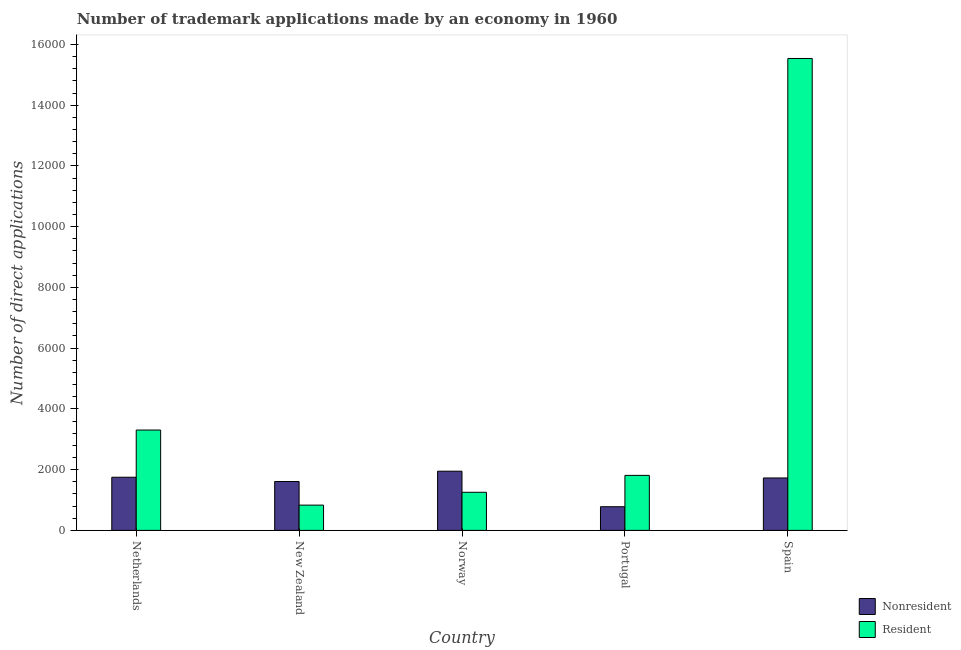How many different coloured bars are there?
Make the answer very short. 2. How many groups of bars are there?
Provide a succinct answer. 5. Are the number of bars per tick equal to the number of legend labels?
Make the answer very short. Yes. Are the number of bars on each tick of the X-axis equal?
Keep it short and to the point. Yes. How many bars are there on the 4th tick from the left?
Offer a very short reply. 2. How many bars are there on the 5th tick from the right?
Keep it short and to the point. 2. What is the number of trademark applications made by residents in New Zealand?
Offer a terse response. 832. Across all countries, what is the maximum number of trademark applications made by non residents?
Give a very brief answer. 1949. Across all countries, what is the minimum number of trademark applications made by non residents?
Offer a very short reply. 779. In which country was the number of trademark applications made by non residents maximum?
Give a very brief answer. Norway. In which country was the number of trademark applications made by residents minimum?
Ensure brevity in your answer.  New Zealand. What is the total number of trademark applications made by non residents in the graph?
Your answer should be very brief. 7813. What is the difference between the number of trademark applications made by residents in New Zealand and that in Portugal?
Your answer should be compact. -979. What is the difference between the number of trademark applications made by residents in Norway and the number of trademark applications made by non residents in Spain?
Your response must be concise. -471. What is the average number of trademark applications made by residents per country?
Offer a very short reply. 4547.8. What is the difference between the number of trademark applications made by non residents and number of trademark applications made by residents in Spain?
Make the answer very short. -1.38e+04. What is the ratio of the number of trademark applications made by residents in Portugal to that in Spain?
Offer a very short reply. 0.12. Is the number of trademark applications made by non residents in New Zealand less than that in Norway?
Ensure brevity in your answer.  Yes. What is the difference between the highest and the second highest number of trademark applications made by non residents?
Your answer should be very brief. 199. What is the difference between the highest and the lowest number of trademark applications made by non residents?
Offer a very short reply. 1170. Is the sum of the number of trademark applications made by residents in Netherlands and Portugal greater than the maximum number of trademark applications made by non residents across all countries?
Keep it short and to the point. Yes. What does the 1st bar from the left in New Zealand represents?
Your response must be concise. Nonresident. What does the 1st bar from the right in Norway represents?
Provide a short and direct response. Resident. Are all the bars in the graph horizontal?
Make the answer very short. No. Are the values on the major ticks of Y-axis written in scientific E-notation?
Your response must be concise. No. Where does the legend appear in the graph?
Offer a very short reply. Bottom right. What is the title of the graph?
Your answer should be very brief. Number of trademark applications made by an economy in 1960. Does "GDP" appear as one of the legend labels in the graph?
Give a very brief answer. No. What is the label or title of the X-axis?
Ensure brevity in your answer.  Country. What is the label or title of the Y-axis?
Your answer should be compact. Number of direct applications. What is the Number of direct applications of Nonresident in Netherlands?
Keep it short and to the point. 1750. What is the Number of direct applications in Resident in Netherlands?
Offer a terse response. 3304. What is the Number of direct applications in Nonresident in New Zealand?
Give a very brief answer. 1609. What is the Number of direct applications of Resident in New Zealand?
Offer a terse response. 832. What is the Number of direct applications in Nonresident in Norway?
Give a very brief answer. 1949. What is the Number of direct applications of Resident in Norway?
Provide a short and direct response. 1255. What is the Number of direct applications in Nonresident in Portugal?
Offer a terse response. 779. What is the Number of direct applications in Resident in Portugal?
Offer a very short reply. 1811. What is the Number of direct applications in Nonresident in Spain?
Keep it short and to the point. 1726. What is the Number of direct applications in Resident in Spain?
Your response must be concise. 1.55e+04. Across all countries, what is the maximum Number of direct applications of Nonresident?
Make the answer very short. 1949. Across all countries, what is the maximum Number of direct applications of Resident?
Provide a short and direct response. 1.55e+04. Across all countries, what is the minimum Number of direct applications in Nonresident?
Offer a very short reply. 779. Across all countries, what is the minimum Number of direct applications of Resident?
Your answer should be very brief. 832. What is the total Number of direct applications in Nonresident in the graph?
Offer a very short reply. 7813. What is the total Number of direct applications in Resident in the graph?
Your answer should be very brief. 2.27e+04. What is the difference between the Number of direct applications of Nonresident in Netherlands and that in New Zealand?
Your answer should be compact. 141. What is the difference between the Number of direct applications in Resident in Netherlands and that in New Zealand?
Your answer should be compact. 2472. What is the difference between the Number of direct applications of Nonresident in Netherlands and that in Norway?
Your answer should be compact. -199. What is the difference between the Number of direct applications in Resident in Netherlands and that in Norway?
Give a very brief answer. 2049. What is the difference between the Number of direct applications in Nonresident in Netherlands and that in Portugal?
Provide a succinct answer. 971. What is the difference between the Number of direct applications in Resident in Netherlands and that in Portugal?
Your answer should be compact. 1493. What is the difference between the Number of direct applications in Nonresident in Netherlands and that in Spain?
Offer a very short reply. 24. What is the difference between the Number of direct applications of Resident in Netherlands and that in Spain?
Make the answer very short. -1.22e+04. What is the difference between the Number of direct applications of Nonresident in New Zealand and that in Norway?
Provide a short and direct response. -340. What is the difference between the Number of direct applications of Resident in New Zealand and that in Norway?
Make the answer very short. -423. What is the difference between the Number of direct applications in Nonresident in New Zealand and that in Portugal?
Your response must be concise. 830. What is the difference between the Number of direct applications of Resident in New Zealand and that in Portugal?
Offer a very short reply. -979. What is the difference between the Number of direct applications in Nonresident in New Zealand and that in Spain?
Offer a terse response. -117. What is the difference between the Number of direct applications of Resident in New Zealand and that in Spain?
Your answer should be compact. -1.47e+04. What is the difference between the Number of direct applications in Nonresident in Norway and that in Portugal?
Make the answer very short. 1170. What is the difference between the Number of direct applications in Resident in Norway and that in Portugal?
Keep it short and to the point. -556. What is the difference between the Number of direct applications of Nonresident in Norway and that in Spain?
Provide a succinct answer. 223. What is the difference between the Number of direct applications in Resident in Norway and that in Spain?
Ensure brevity in your answer.  -1.43e+04. What is the difference between the Number of direct applications of Nonresident in Portugal and that in Spain?
Your answer should be very brief. -947. What is the difference between the Number of direct applications in Resident in Portugal and that in Spain?
Give a very brief answer. -1.37e+04. What is the difference between the Number of direct applications of Nonresident in Netherlands and the Number of direct applications of Resident in New Zealand?
Keep it short and to the point. 918. What is the difference between the Number of direct applications of Nonresident in Netherlands and the Number of direct applications of Resident in Norway?
Ensure brevity in your answer.  495. What is the difference between the Number of direct applications in Nonresident in Netherlands and the Number of direct applications in Resident in Portugal?
Offer a very short reply. -61. What is the difference between the Number of direct applications in Nonresident in Netherlands and the Number of direct applications in Resident in Spain?
Offer a terse response. -1.38e+04. What is the difference between the Number of direct applications in Nonresident in New Zealand and the Number of direct applications in Resident in Norway?
Your response must be concise. 354. What is the difference between the Number of direct applications in Nonresident in New Zealand and the Number of direct applications in Resident in Portugal?
Offer a very short reply. -202. What is the difference between the Number of direct applications in Nonresident in New Zealand and the Number of direct applications in Resident in Spain?
Keep it short and to the point. -1.39e+04. What is the difference between the Number of direct applications in Nonresident in Norway and the Number of direct applications in Resident in Portugal?
Make the answer very short. 138. What is the difference between the Number of direct applications in Nonresident in Norway and the Number of direct applications in Resident in Spain?
Keep it short and to the point. -1.36e+04. What is the difference between the Number of direct applications of Nonresident in Portugal and the Number of direct applications of Resident in Spain?
Offer a very short reply. -1.48e+04. What is the average Number of direct applications in Nonresident per country?
Your response must be concise. 1562.6. What is the average Number of direct applications of Resident per country?
Offer a terse response. 4547.8. What is the difference between the Number of direct applications of Nonresident and Number of direct applications of Resident in Netherlands?
Offer a terse response. -1554. What is the difference between the Number of direct applications in Nonresident and Number of direct applications in Resident in New Zealand?
Your answer should be compact. 777. What is the difference between the Number of direct applications of Nonresident and Number of direct applications of Resident in Norway?
Provide a succinct answer. 694. What is the difference between the Number of direct applications in Nonresident and Number of direct applications in Resident in Portugal?
Your answer should be very brief. -1032. What is the difference between the Number of direct applications in Nonresident and Number of direct applications in Resident in Spain?
Your response must be concise. -1.38e+04. What is the ratio of the Number of direct applications of Nonresident in Netherlands to that in New Zealand?
Give a very brief answer. 1.09. What is the ratio of the Number of direct applications in Resident in Netherlands to that in New Zealand?
Offer a very short reply. 3.97. What is the ratio of the Number of direct applications of Nonresident in Netherlands to that in Norway?
Your response must be concise. 0.9. What is the ratio of the Number of direct applications in Resident in Netherlands to that in Norway?
Your response must be concise. 2.63. What is the ratio of the Number of direct applications in Nonresident in Netherlands to that in Portugal?
Offer a very short reply. 2.25. What is the ratio of the Number of direct applications of Resident in Netherlands to that in Portugal?
Your response must be concise. 1.82. What is the ratio of the Number of direct applications in Nonresident in Netherlands to that in Spain?
Make the answer very short. 1.01. What is the ratio of the Number of direct applications in Resident in Netherlands to that in Spain?
Offer a terse response. 0.21. What is the ratio of the Number of direct applications of Nonresident in New Zealand to that in Norway?
Provide a short and direct response. 0.83. What is the ratio of the Number of direct applications of Resident in New Zealand to that in Norway?
Make the answer very short. 0.66. What is the ratio of the Number of direct applications of Nonresident in New Zealand to that in Portugal?
Your response must be concise. 2.07. What is the ratio of the Number of direct applications in Resident in New Zealand to that in Portugal?
Provide a short and direct response. 0.46. What is the ratio of the Number of direct applications of Nonresident in New Zealand to that in Spain?
Offer a very short reply. 0.93. What is the ratio of the Number of direct applications of Resident in New Zealand to that in Spain?
Offer a terse response. 0.05. What is the ratio of the Number of direct applications in Nonresident in Norway to that in Portugal?
Your answer should be very brief. 2.5. What is the ratio of the Number of direct applications in Resident in Norway to that in Portugal?
Your answer should be very brief. 0.69. What is the ratio of the Number of direct applications of Nonresident in Norway to that in Spain?
Make the answer very short. 1.13. What is the ratio of the Number of direct applications in Resident in Norway to that in Spain?
Make the answer very short. 0.08. What is the ratio of the Number of direct applications of Nonresident in Portugal to that in Spain?
Make the answer very short. 0.45. What is the ratio of the Number of direct applications of Resident in Portugal to that in Spain?
Offer a very short reply. 0.12. What is the difference between the highest and the second highest Number of direct applications of Nonresident?
Your response must be concise. 199. What is the difference between the highest and the second highest Number of direct applications in Resident?
Keep it short and to the point. 1.22e+04. What is the difference between the highest and the lowest Number of direct applications of Nonresident?
Ensure brevity in your answer.  1170. What is the difference between the highest and the lowest Number of direct applications of Resident?
Offer a terse response. 1.47e+04. 